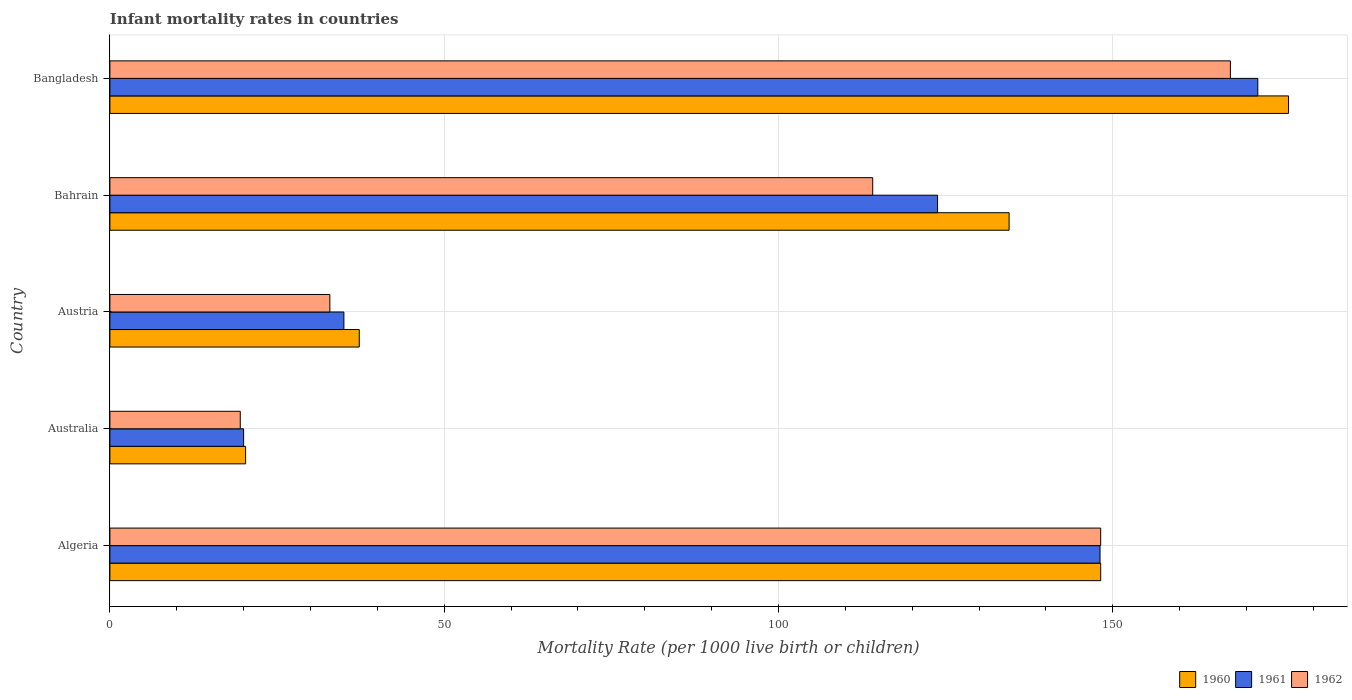How many groups of bars are there?
Your answer should be compact. 5. Are the number of bars on each tick of the Y-axis equal?
Give a very brief answer. Yes. How many bars are there on the 1st tick from the top?
Your answer should be very brief. 3. In how many cases, is the number of bars for a given country not equal to the number of legend labels?
Make the answer very short. 0. What is the infant mortality rate in 1961 in Bangladesh?
Provide a succinct answer. 171.7. Across all countries, what is the maximum infant mortality rate in 1960?
Give a very brief answer. 176.3. Across all countries, what is the minimum infant mortality rate in 1960?
Offer a very short reply. 20.3. What is the total infant mortality rate in 1960 in the graph?
Offer a very short reply. 516.6. What is the difference between the infant mortality rate in 1961 in Algeria and that in Australia?
Your answer should be compact. 128.1. What is the difference between the infant mortality rate in 1962 in Algeria and the infant mortality rate in 1960 in Bahrain?
Provide a short and direct response. 13.7. What is the average infant mortality rate in 1961 per country?
Offer a very short reply. 99.72. What is the difference between the infant mortality rate in 1961 and infant mortality rate in 1960 in Austria?
Your answer should be very brief. -2.3. What is the ratio of the infant mortality rate in 1960 in Austria to that in Bangladesh?
Your answer should be very brief. 0.21. Is the infant mortality rate in 1962 in Algeria less than that in Austria?
Ensure brevity in your answer.  No. What is the difference between the highest and the second highest infant mortality rate in 1962?
Your answer should be very brief. 19.4. What is the difference between the highest and the lowest infant mortality rate in 1961?
Your response must be concise. 151.7. How many bars are there?
Offer a very short reply. 15. How many countries are there in the graph?
Ensure brevity in your answer.  5. What is the difference between two consecutive major ticks on the X-axis?
Your response must be concise. 50. Does the graph contain any zero values?
Provide a short and direct response. No. Does the graph contain grids?
Offer a terse response. Yes. Where does the legend appear in the graph?
Offer a terse response. Bottom right. How many legend labels are there?
Offer a very short reply. 3. What is the title of the graph?
Provide a short and direct response. Infant mortality rates in countries. Does "1967" appear as one of the legend labels in the graph?
Make the answer very short. No. What is the label or title of the X-axis?
Offer a terse response. Mortality Rate (per 1000 live birth or children). What is the Mortality Rate (per 1000 live birth or children) of 1960 in Algeria?
Ensure brevity in your answer.  148.2. What is the Mortality Rate (per 1000 live birth or children) in 1961 in Algeria?
Your response must be concise. 148.1. What is the Mortality Rate (per 1000 live birth or children) of 1962 in Algeria?
Provide a short and direct response. 148.2. What is the Mortality Rate (per 1000 live birth or children) in 1960 in Australia?
Ensure brevity in your answer.  20.3. What is the Mortality Rate (per 1000 live birth or children) in 1960 in Austria?
Your response must be concise. 37.3. What is the Mortality Rate (per 1000 live birth or children) in 1962 in Austria?
Your answer should be compact. 32.9. What is the Mortality Rate (per 1000 live birth or children) in 1960 in Bahrain?
Ensure brevity in your answer.  134.5. What is the Mortality Rate (per 1000 live birth or children) in 1961 in Bahrain?
Give a very brief answer. 123.8. What is the Mortality Rate (per 1000 live birth or children) in 1962 in Bahrain?
Keep it short and to the point. 114.1. What is the Mortality Rate (per 1000 live birth or children) of 1960 in Bangladesh?
Make the answer very short. 176.3. What is the Mortality Rate (per 1000 live birth or children) of 1961 in Bangladesh?
Provide a succinct answer. 171.7. What is the Mortality Rate (per 1000 live birth or children) in 1962 in Bangladesh?
Offer a terse response. 167.6. Across all countries, what is the maximum Mortality Rate (per 1000 live birth or children) in 1960?
Your response must be concise. 176.3. Across all countries, what is the maximum Mortality Rate (per 1000 live birth or children) in 1961?
Offer a terse response. 171.7. Across all countries, what is the maximum Mortality Rate (per 1000 live birth or children) in 1962?
Provide a succinct answer. 167.6. Across all countries, what is the minimum Mortality Rate (per 1000 live birth or children) of 1960?
Provide a succinct answer. 20.3. Across all countries, what is the minimum Mortality Rate (per 1000 live birth or children) of 1961?
Offer a very short reply. 20. Across all countries, what is the minimum Mortality Rate (per 1000 live birth or children) in 1962?
Your answer should be very brief. 19.5. What is the total Mortality Rate (per 1000 live birth or children) in 1960 in the graph?
Your answer should be very brief. 516.6. What is the total Mortality Rate (per 1000 live birth or children) of 1961 in the graph?
Your response must be concise. 498.6. What is the total Mortality Rate (per 1000 live birth or children) in 1962 in the graph?
Offer a terse response. 482.3. What is the difference between the Mortality Rate (per 1000 live birth or children) in 1960 in Algeria and that in Australia?
Your answer should be very brief. 127.9. What is the difference between the Mortality Rate (per 1000 live birth or children) in 1961 in Algeria and that in Australia?
Ensure brevity in your answer.  128.1. What is the difference between the Mortality Rate (per 1000 live birth or children) in 1962 in Algeria and that in Australia?
Make the answer very short. 128.7. What is the difference between the Mortality Rate (per 1000 live birth or children) of 1960 in Algeria and that in Austria?
Ensure brevity in your answer.  110.9. What is the difference between the Mortality Rate (per 1000 live birth or children) in 1961 in Algeria and that in Austria?
Offer a terse response. 113.1. What is the difference between the Mortality Rate (per 1000 live birth or children) in 1962 in Algeria and that in Austria?
Give a very brief answer. 115.3. What is the difference between the Mortality Rate (per 1000 live birth or children) in 1961 in Algeria and that in Bahrain?
Give a very brief answer. 24.3. What is the difference between the Mortality Rate (per 1000 live birth or children) of 1962 in Algeria and that in Bahrain?
Your answer should be compact. 34.1. What is the difference between the Mortality Rate (per 1000 live birth or children) in 1960 in Algeria and that in Bangladesh?
Your answer should be compact. -28.1. What is the difference between the Mortality Rate (per 1000 live birth or children) in 1961 in Algeria and that in Bangladesh?
Your answer should be compact. -23.6. What is the difference between the Mortality Rate (per 1000 live birth or children) in 1962 in Algeria and that in Bangladesh?
Provide a short and direct response. -19.4. What is the difference between the Mortality Rate (per 1000 live birth or children) of 1961 in Australia and that in Austria?
Make the answer very short. -15. What is the difference between the Mortality Rate (per 1000 live birth or children) of 1960 in Australia and that in Bahrain?
Keep it short and to the point. -114.2. What is the difference between the Mortality Rate (per 1000 live birth or children) of 1961 in Australia and that in Bahrain?
Make the answer very short. -103.8. What is the difference between the Mortality Rate (per 1000 live birth or children) in 1962 in Australia and that in Bahrain?
Provide a succinct answer. -94.6. What is the difference between the Mortality Rate (per 1000 live birth or children) of 1960 in Australia and that in Bangladesh?
Your answer should be very brief. -156. What is the difference between the Mortality Rate (per 1000 live birth or children) in 1961 in Australia and that in Bangladesh?
Provide a short and direct response. -151.7. What is the difference between the Mortality Rate (per 1000 live birth or children) in 1962 in Australia and that in Bangladesh?
Offer a terse response. -148.1. What is the difference between the Mortality Rate (per 1000 live birth or children) of 1960 in Austria and that in Bahrain?
Provide a succinct answer. -97.2. What is the difference between the Mortality Rate (per 1000 live birth or children) in 1961 in Austria and that in Bahrain?
Provide a short and direct response. -88.8. What is the difference between the Mortality Rate (per 1000 live birth or children) of 1962 in Austria and that in Bahrain?
Ensure brevity in your answer.  -81.2. What is the difference between the Mortality Rate (per 1000 live birth or children) in 1960 in Austria and that in Bangladesh?
Ensure brevity in your answer.  -139. What is the difference between the Mortality Rate (per 1000 live birth or children) in 1961 in Austria and that in Bangladesh?
Your answer should be very brief. -136.7. What is the difference between the Mortality Rate (per 1000 live birth or children) in 1962 in Austria and that in Bangladesh?
Offer a very short reply. -134.7. What is the difference between the Mortality Rate (per 1000 live birth or children) in 1960 in Bahrain and that in Bangladesh?
Make the answer very short. -41.8. What is the difference between the Mortality Rate (per 1000 live birth or children) of 1961 in Bahrain and that in Bangladesh?
Your answer should be very brief. -47.9. What is the difference between the Mortality Rate (per 1000 live birth or children) of 1962 in Bahrain and that in Bangladesh?
Offer a terse response. -53.5. What is the difference between the Mortality Rate (per 1000 live birth or children) of 1960 in Algeria and the Mortality Rate (per 1000 live birth or children) of 1961 in Australia?
Keep it short and to the point. 128.2. What is the difference between the Mortality Rate (per 1000 live birth or children) of 1960 in Algeria and the Mortality Rate (per 1000 live birth or children) of 1962 in Australia?
Your response must be concise. 128.7. What is the difference between the Mortality Rate (per 1000 live birth or children) in 1961 in Algeria and the Mortality Rate (per 1000 live birth or children) in 1962 in Australia?
Keep it short and to the point. 128.6. What is the difference between the Mortality Rate (per 1000 live birth or children) in 1960 in Algeria and the Mortality Rate (per 1000 live birth or children) in 1961 in Austria?
Offer a very short reply. 113.2. What is the difference between the Mortality Rate (per 1000 live birth or children) of 1960 in Algeria and the Mortality Rate (per 1000 live birth or children) of 1962 in Austria?
Give a very brief answer. 115.3. What is the difference between the Mortality Rate (per 1000 live birth or children) of 1961 in Algeria and the Mortality Rate (per 1000 live birth or children) of 1962 in Austria?
Make the answer very short. 115.2. What is the difference between the Mortality Rate (per 1000 live birth or children) of 1960 in Algeria and the Mortality Rate (per 1000 live birth or children) of 1961 in Bahrain?
Your answer should be very brief. 24.4. What is the difference between the Mortality Rate (per 1000 live birth or children) of 1960 in Algeria and the Mortality Rate (per 1000 live birth or children) of 1962 in Bahrain?
Offer a terse response. 34.1. What is the difference between the Mortality Rate (per 1000 live birth or children) of 1960 in Algeria and the Mortality Rate (per 1000 live birth or children) of 1961 in Bangladesh?
Keep it short and to the point. -23.5. What is the difference between the Mortality Rate (per 1000 live birth or children) in 1960 in Algeria and the Mortality Rate (per 1000 live birth or children) in 1962 in Bangladesh?
Provide a succinct answer. -19.4. What is the difference between the Mortality Rate (per 1000 live birth or children) in 1961 in Algeria and the Mortality Rate (per 1000 live birth or children) in 1962 in Bangladesh?
Your answer should be compact. -19.5. What is the difference between the Mortality Rate (per 1000 live birth or children) in 1960 in Australia and the Mortality Rate (per 1000 live birth or children) in 1961 in Austria?
Your answer should be compact. -14.7. What is the difference between the Mortality Rate (per 1000 live birth or children) in 1961 in Australia and the Mortality Rate (per 1000 live birth or children) in 1962 in Austria?
Offer a very short reply. -12.9. What is the difference between the Mortality Rate (per 1000 live birth or children) of 1960 in Australia and the Mortality Rate (per 1000 live birth or children) of 1961 in Bahrain?
Give a very brief answer. -103.5. What is the difference between the Mortality Rate (per 1000 live birth or children) of 1960 in Australia and the Mortality Rate (per 1000 live birth or children) of 1962 in Bahrain?
Make the answer very short. -93.8. What is the difference between the Mortality Rate (per 1000 live birth or children) of 1961 in Australia and the Mortality Rate (per 1000 live birth or children) of 1962 in Bahrain?
Keep it short and to the point. -94.1. What is the difference between the Mortality Rate (per 1000 live birth or children) in 1960 in Australia and the Mortality Rate (per 1000 live birth or children) in 1961 in Bangladesh?
Provide a short and direct response. -151.4. What is the difference between the Mortality Rate (per 1000 live birth or children) of 1960 in Australia and the Mortality Rate (per 1000 live birth or children) of 1962 in Bangladesh?
Provide a short and direct response. -147.3. What is the difference between the Mortality Rate (per 1000 live birth or children) of 1961 in Australia and the Mortality Rate (per 1000 live birth or children) of 1962 in Bangladesh?
Your response must be concise. -147.6. What is the difference between the Mortality Rate (per 1000 live birth or children) in 1960 in Austria and the Mortality Rate (per 1000 live birth or children) in 1961 in Bahrain?
Offer a terse response. -86.5. What is the difference between the Mortality Rate (per 1000 live birth or children) of 1960 in Austria and the Mortality Rate (per 1000 live birth or children) of 1962 in Bahrain?
Give a very brief answer. -76.8. What is the difference between the Mortality Rate (per 1000 live birth or children) in 1961 in Austria and the Mortality Rate (per 1000 live birth or children) in 1962 in Bahrain?
Make the answer very short. -79.1. What is the difference between the Mortality Rate (per 1000 live birth or children) of 1960 in Austria and the Mortality Rate (per 1000 live birth or children) of 1961 in Bangladesh?
Make the answer very short. -134.4. What is the difference between the Mortality Rate (per 1000 live birth or children) of 1960 in Austria and the Mortality Rate (per 1000 live birth or children) of 1962 in Bangladesh?
Offer a terse response. -130.3. What is the difference between the Mortality Rate (per 1000 live birth or children) in 1961 in Austria and the Mortality Rate (per 1000 live birth or children) in 1962 in Bangladesh?
Keep it short and to the point. -132.6. What is the difference between the Mortality Rate (per 1000 live birth or children) in 1960 in Bahrain and the Mortality Rate (per 1000 live birth or children) in 1961 in Bangladesh?
Ensure brevity in your answer.  -37.2. What is the difference between the Mortality Rate (per 1000 live birth or children) of 1960 in Bahrain and the Mortality Rate (per 1000 live birth or children) of 1962 in Bangladesh?
Your answer should be very brief. -33.1. What is the difference between the Mortality Rate (per 1000 live birth or children) in 1961 in Bahrain and the Mortality Rate (per 1000 live birth or children) in 1962 in Bangladesh?
Your response must be concise. -43.8. What is the average Mortality Rate (per 1000 live birth or children) of 1960 per country?
Offer a terse response. 103.32. What is the average Mortality Rate (per 1000 live birth or children) in 1961 per country?
Keep it short and to the point. 99.72. What is the average Mortality Rate (per 1000 live birth or children) of 1962 per country?
Your answer should be compact. 96.46. What is the difference between the Mortality Rate (per 1000 live birth or children) in 1960 and Mortality Rate (per 1000 live birth or children) in 1961 in Algeria?
Provide a succinct answer. 0.1. What is the difference between the Mortality Rate (per 1000 live birth or children) of 1961 and Mortality Rate (per 1000 live birth or children) of 1962 in Algeria?
Your response must be concise. -0.1. What is the difference between the Mortality Rate (per 1000 live birth or children) of 1960 and Mortality Rate (per 1000 live birth or children) of 1961 in Australia?
Make the answer very short. 0.3. What is the difference between the Mortality Rate (per 1000 live birth or children) in 1960 and Mortality Rate (per 1000 live birth or children) in 1962 in Australia?
Keep it short and to the point. 0.8. What is the difference between the Mortality Rate (per 1000 live birth or children) in 1960 and Mortality Rate (per 1000 live birth or children) in 1962 in Austria?
Your answer should be very brief. 4.4. What is the difference between the Mortality Rate (per 1000 live birth or children) in 1961 and Mortality Rate (per 1000 live birth or children) in 1962 in Austria?
Keep it short and to the point. 2.1. What is the difference between the Mortality Rate (per 1000 live birth or children) in 1960 and Mortality Rate (per 1000 live birth or children) in 1962 in Bahrain?
Give a very brief answer. 20.4. What is the ratio of the Mortality Rate (per 1000 live birth or children) in 1960 in Algeria to that in Australia?
Provide a short and direct response. 7.3. What is the ratio of the Mortality Rate (per 1000 live birth or children) in 1961 in Algeria to that in Australia?
Offer a very short reply. 7.41. What is the ratio of the Mortality Rate (per 1000 live birth or children) of 1960 in Algeria to that in Austria?
Offer a very short reply. 3.97. What is the ratio of the Mortality Rate (per 1000 live birth or children) in 1961 in Algeria to that in Austria?
Provide a succinct answer. 4.23. What is the ratio of the Mortality Rate (per 1000 live birth or children) of 1962 in Algeria to that in Austria?
Keep it short and to the point. 4.5. What is the ratio of the Mortality Rate (per 1000 live birth or children) in 1960 in Algeria to that in Bahrain?
Offer a very short reply. 1.1. What is the ratio of the Mortality Rate (per 1000 live birth or children) of 1961 in Algeria to that in Bahrain?
Provide a succinct answer. 1.2. What is the ratio of the Mortality Rate (per 1000 live birth or children) of 1962 in Algeria to that in Bahrain?
Make the answer very short. 1.3. What is the ratio of the Mortality Rate (per 1000 live birth or children) in 1960 in Algeria to that in Bangladesh?
Provide a succinct answer. 0.84. What is the ratio of the Mortality Rate (per 1000 live birth or children) of 1961 in Algeria to that in Bangladesh?
Your response must be concise. 0.86. What is the ratio of the Mortality Rate (per 1000 live birth or children) in 1962 in Algeria to that in Bangladesh?
Offer a very short reply. 0.88. What is the ratio of the Mortality Rate (per 1000 live birth or children) of 1960 in Australia to that in Austria?
Offer a terse response. 0.54. What is the ratio of the Mortality Rate (per 1000 live birth or children) in 1961 in Australia to that in Austria?
Your response must be concise. 0.57. What is the ratio of the Mortality Rate (per 1000 live birth or children) in 1962 in Australia to that in Austria?
Give a very brief answer. 0.59. What is the ratio of the Mortality Rate (per 1000 live birth or children) of 1960 in Australia to that in Bahrain?
Provide a short and direct response. 0.15. What is the ratio of the Mortality Rate (per 1000 live birth or children) in 1961 in Australia to that in Bahrain?
Keep it short and to the point. 0.16. What is the ratio of the Mortality Rate (per 1000 live birth or children) of 1962 in Australia to that in Bahrain?
Give a very brief answer. 0.17. What is the ratio of the Mortality Rate (per 1000 live birth or children) in 1960 in Australia to that in Bangladesh?
Provide a short and direct response. 0.12. What is the ratio of the Mortality Rate (per 1000 live birth or children) of 1961 in Australia to that in Bangladesh?
Give a very brief answer. 0.12. What is the ratio of the Mortality Rate (per 1000 live birth or children) of 1962 in Australia to that in Bangladesh?
Ensure brevity in your answer.  0.12. What is the ratio of the Mortality Rate (per 1000 live birth or children) of 1960 in Austria to that in Bahrain?
Provide a succinct answer. 0.28. What is the ratio of the Mortality Rate (per 1000 live birth or children) of 1961 in Austria to that in Bahrain?
Your response must be concise. 0.28. What is the ratio of the Mortality Rate (per 1000 live birth or children) of 1962 in Austria to that in Bahrain?
Your response must be concise. 0.29. What is the ratio of the Mortality Rate (per 1000 live birth or children) of 1960 in Austria to that in Bangladesh?
Your answer should be very brief. 0.21. What is the ratio of the Mortality Rate (per 1000 live birth or children) of 1961 in Austria to that in Bangladesh?
Your response must be concise. 0.2. What is the ratio of the Mortality Rate (per 1000 live birth or children) in 1962 in Austria to that in Bangladesh?
Your answer should be compact. 0.2. What is the ratio of the Mortality Rate (per 1000 live birth or children) in 1960 in Bahrain to that in Bangladesh?
Your answer should be very brief. 0.76. What is the ratio of the Mortality Rate (per 1000 live birth or children) in 1961 in Bahrain to that in Bangladesh?
Your response must be concise. 0.72. What is the ratio of the Mortality Rate (per 1000 live birth or children) in 1962 in Bahrain to that in Bangladesh?
Provide a short and direct response. 0.68. What is the difference between the highest and the second highest Mortality Rate (per 1000 live birth or children) in 1960?
Ensure brevity in your answer.  28.1. What is the difference between the highest and the second highest Mortality Rate (per 1000 live birth or children) in 1961?
Offer a terse response. 23.6. What is the difference between the highest and the second highest Mortality Rate (per 1000 live birth or children) of 1962?
Give a very brief answer. 19.4. What is the difference between the highest and the lowest Mortality Rate (per 1000 live birth or children) of 1960?
Provide a short and direct response. 156. What is the difference between the highest and the lowest Mortality Rate (per 1000 live birth or children) in 1961?
Your answer should be very brief. 151.7. What is the difference between the highest and the lowest Mortality Rate (per 1000 live birth or children) of 1962?
Your response must be concise. 148.1. 